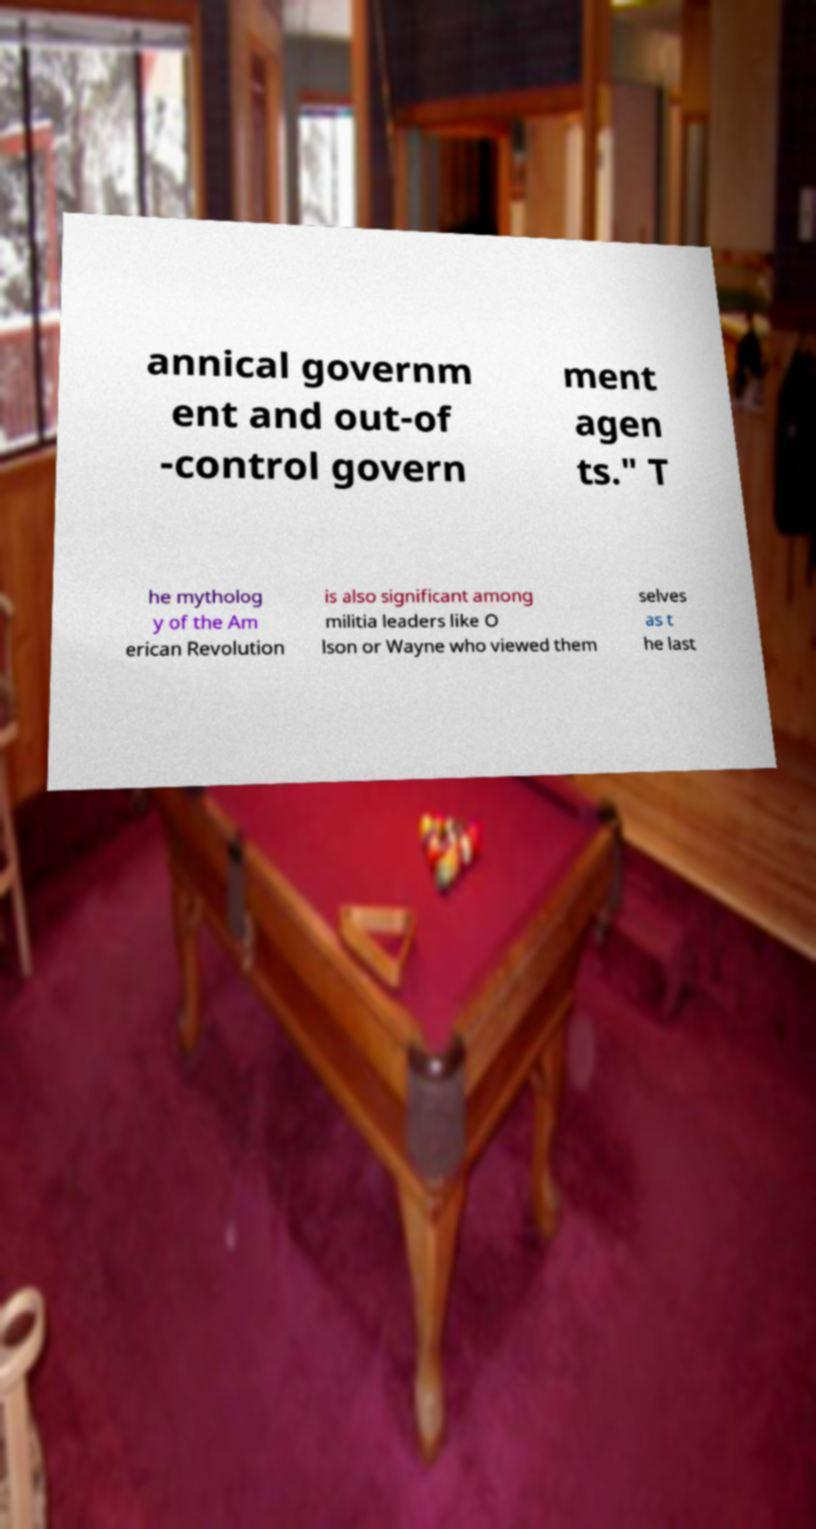Please read and relay the text visible in this image. What does it say? annical governm ent and out-of -control govern ment agen ts." T he mytholog y of the Am erican Revolution is also significant among militia leaders like O lson or Wayne who viewed them selves as t he last 